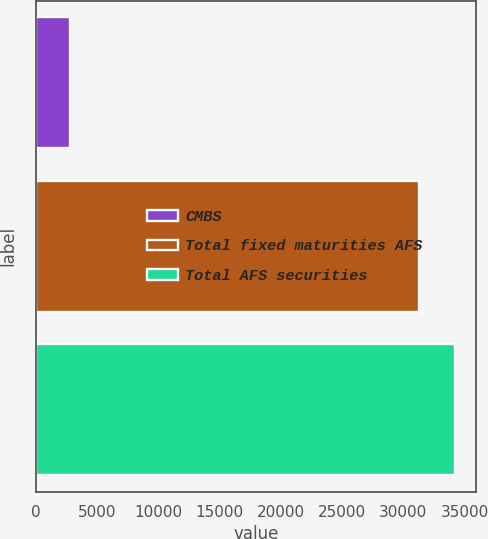<chart> <loc_0><loc_0><loc_500><loc_500><bar_chart><fcel>CMBS<fcel>Total fixed maturities AFS<fcel>Total AFS securities<nl><fcel>2772<fcel>31296<fcel>34236.2<nl></chart> 